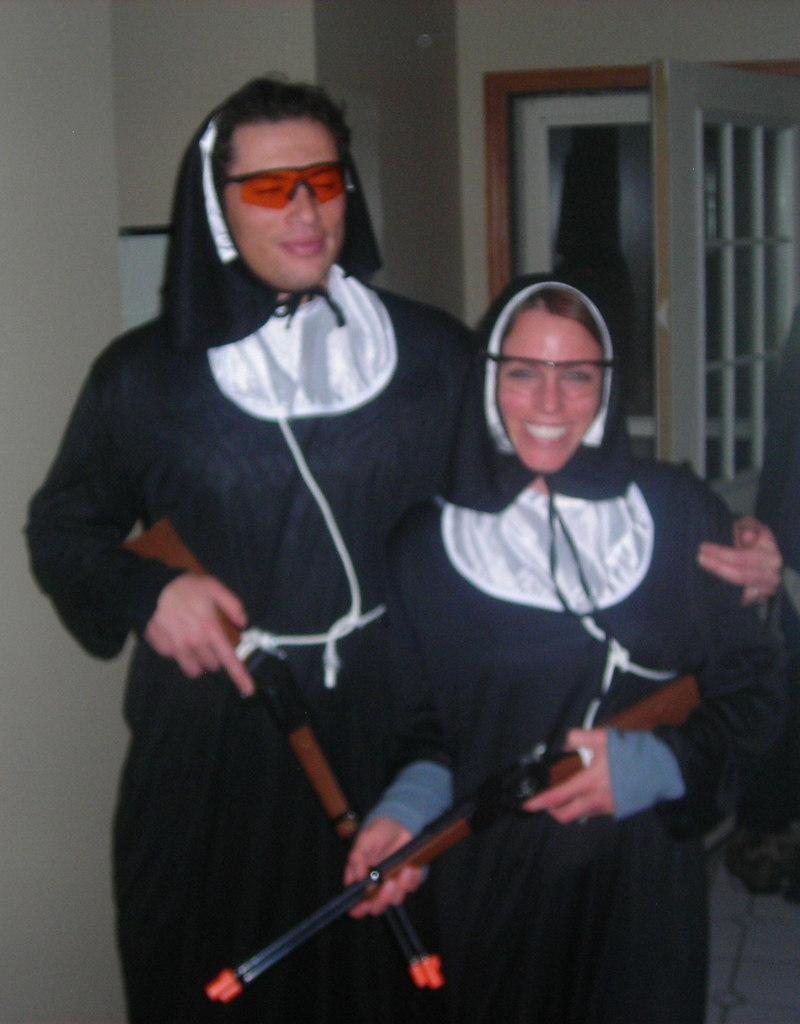What is the man in the image holding? The man is holding a gun in the image. What is the man wearing? The man is wearing a black dress in the image. What is the woman in the image doing? The woman is smiling in the image. What can be seen in the background of the image? There is a window in the background of the image. What type of lamp can be seen in the image? There is no lamp present in the image. What type of silver object is the man using to cook a stew in the image? There is no silver object or stew present in the image. 